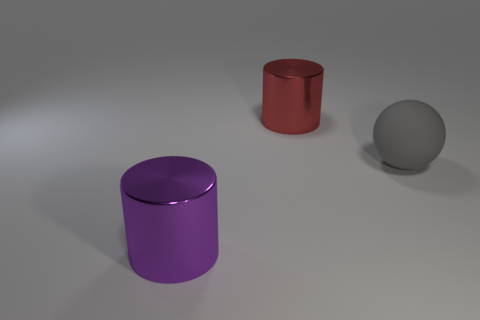What time of day does the lighting in the scene suggest? The lighting in the scene does not strongly indicate a specific time of day as it seems to be artificial and controlled, likely from a studio environment with a neutral background. 